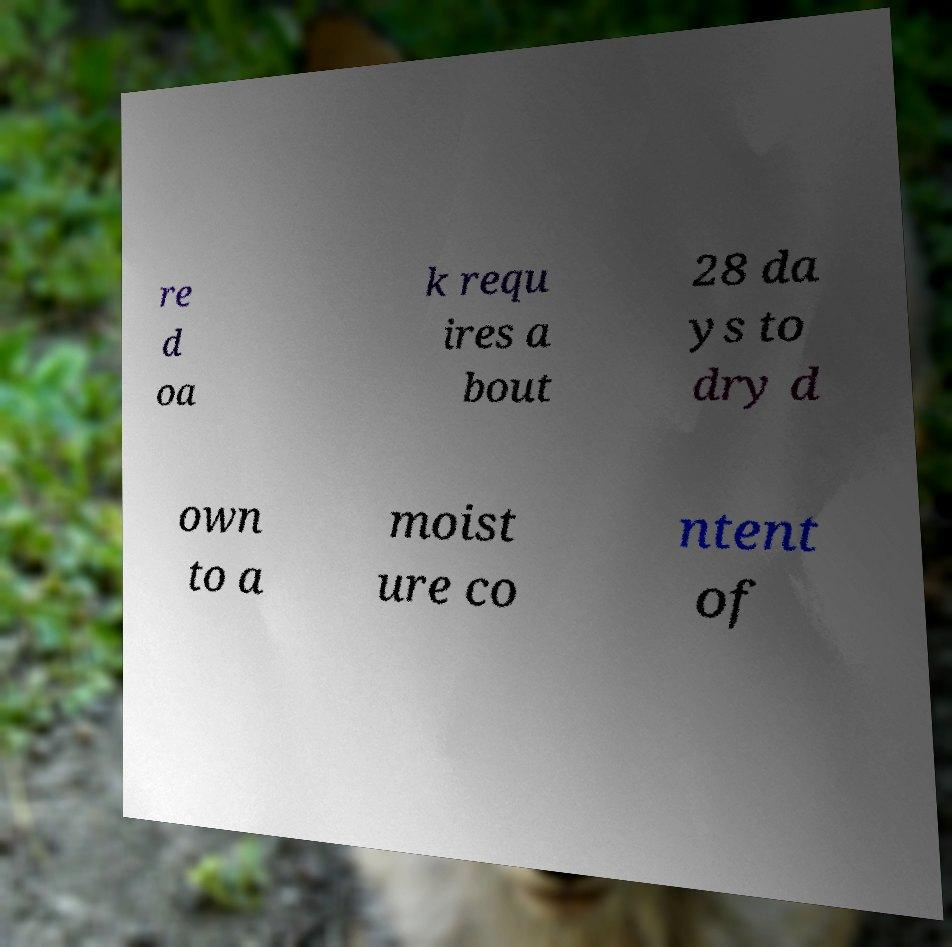Could you extract and type out the text from this image? re d oa k requ ires a bout 28 da ys to dry d own to a moist ure co ntent of 